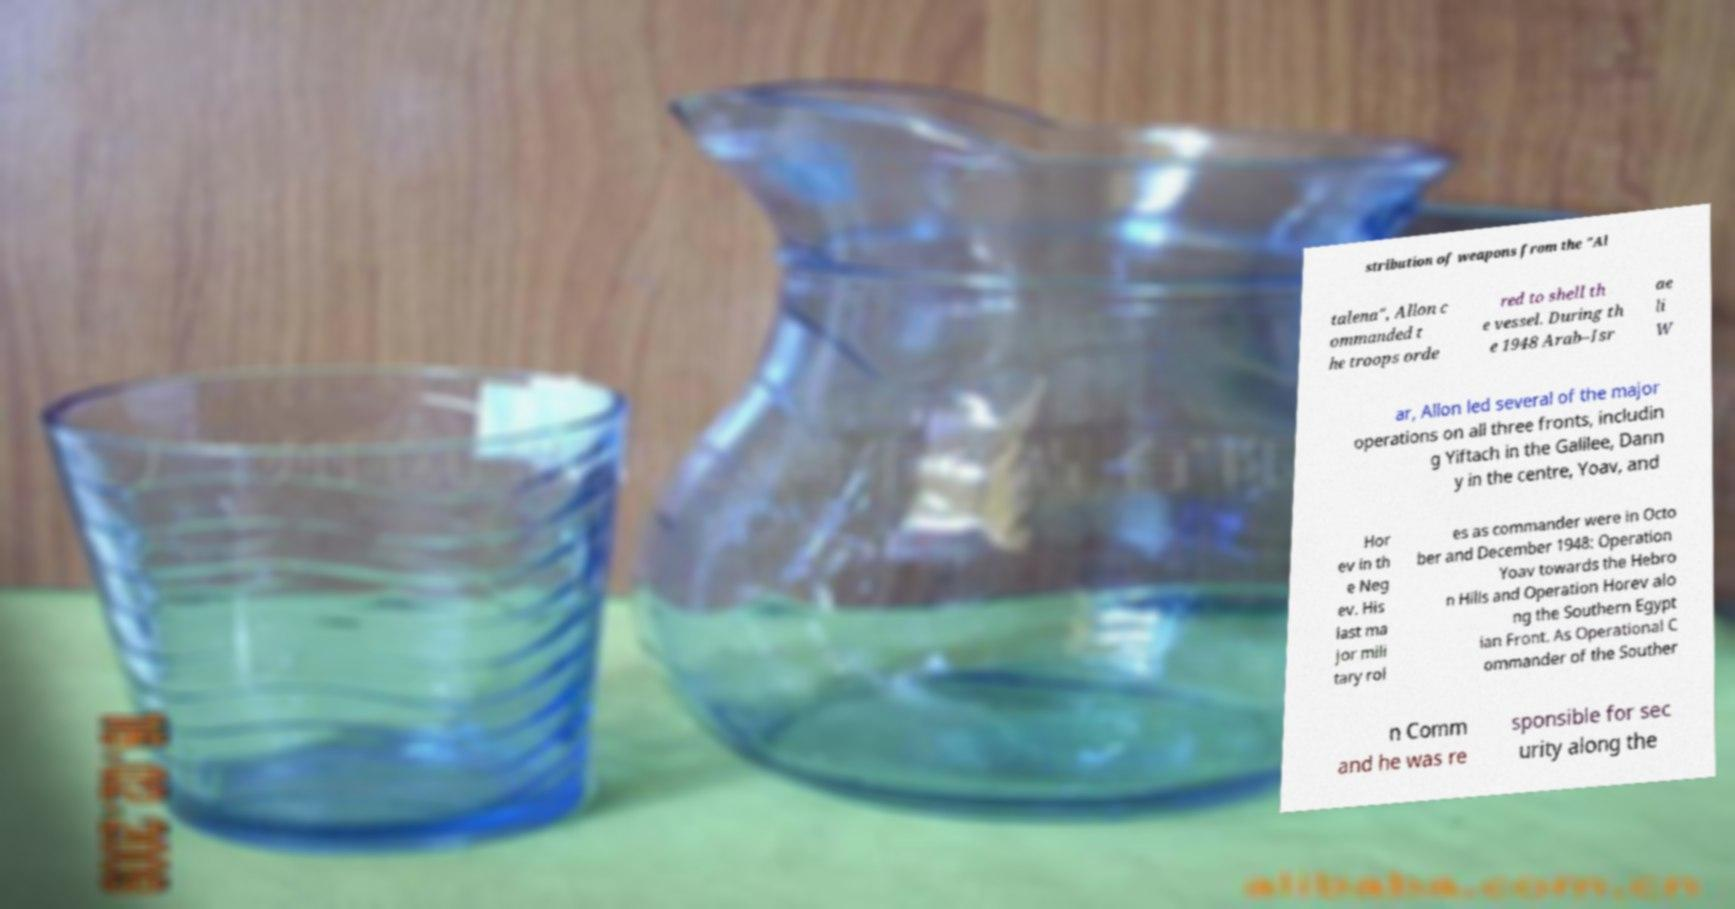Can you accurately transcribe the text from the provided image for me? stribution of weapons from the "Al talena", Allon c ommanded t he troops orde red to shell th e vessel. During th e 1948 Arab–Isr ae li W ar, Allon led several of the major operations on all three fronts, includin g Yiftach in the Galilee, Dann y in the centre, Yoav, and Hor ev in th e Neg ev. His last ma jor mili tary rol es as commander were in Octo ber and December 1948: Operation Yoav towards the Hebro n Hills and Operation Horev alo ng the Southern Egypt ian Front. As Operational C ommander of the Souther n Comm and he was re sponsible for sec urity along the 